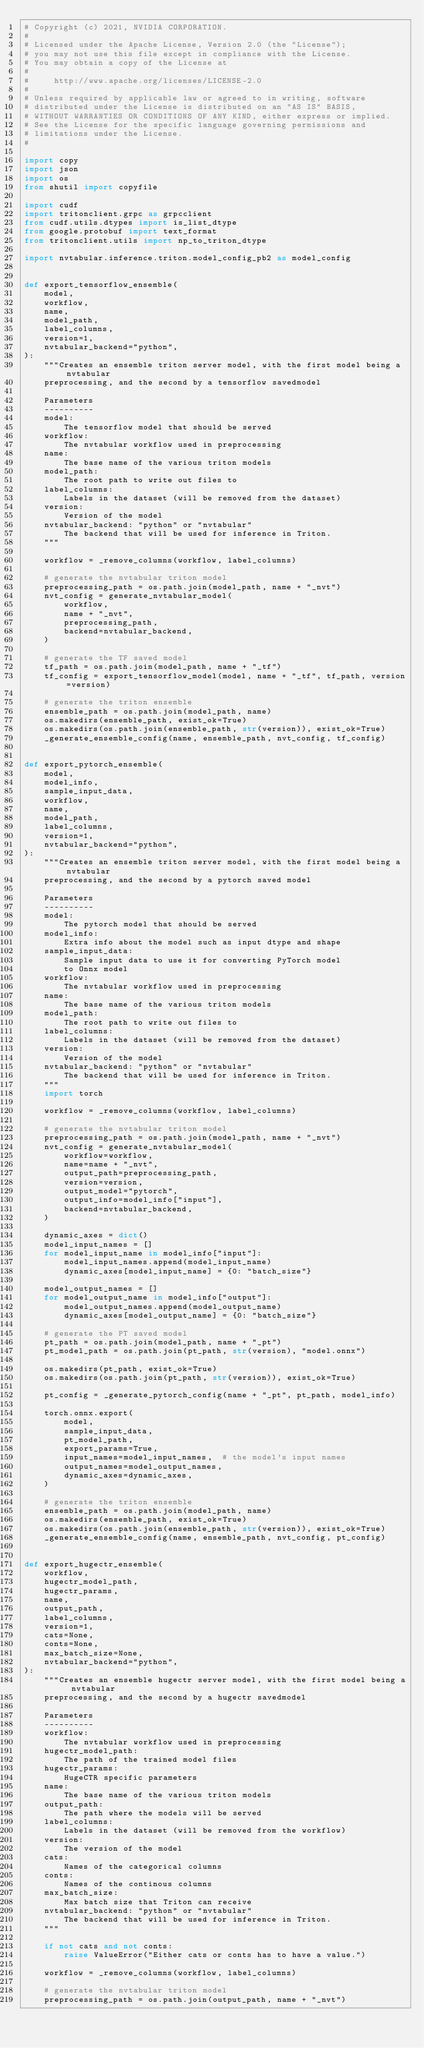Convert code to text. <code><loc_0><loc_0><loc_500><loc_500><_Python_># Copyright (c) 2021, NVIDIA CORPORATION.
#
# Licensed under the Apache License, Version 2.0 (the "License");
# you may not use this file except in compliance with the License.
# You may obtain a copy of the License at
#
#     http://www.apache.org/licenses/LICENSE-2.0
#
# Unless required by applicable law or agreed to in writing, software
# distributed under the License is distributed on an "AS IS" BASIS,
# WITHOUT WARRANTIES OR CONDITIONS OF ANY KIND, either express or implied.
# See the License for the specific language governing permissions and
# limitations under the License.
#

import copy
import json
import os
from shutil import copyfile

import cudf
import tritonclient.grpc as grpcclient
from cudf.utils.dtypes import is_list_dtype
from google.protobuf import text_format
from tritonclient.utils import np_to_triton_dtype

import nvtabular.inference.triton.model_config_pb2 as model_config


def export_tensorflow_ensemble(
    model,
    workflow,
    name,
    model_path,
    label_columns,
    version=1,
    nvtabular_backend="python",
):
    """Creates an ensemble triton server model, with the first model being a nvtabular
    preprocessing, and the second by a tensorflow savedmodel

    Parameters
    ----------
    model:
        The tensorflow model that should be served
    workflow:
        The nvtabular workflow used in preprocessing
    name:
        The base name of the various triton models
    model_path:
        The root path to write out files to
    label_columns:
        Labels in the dataset (will be removed from the dataset)
    version:
        Version of the model
    nvtabular_backend: "python" or "nvtabular"
        The backend that will be used for inference in Triton.
    """

    workflow = _remove_columns(workflow, label_columns)

    # generate the nvtabular triton model
    preprocessing_path = os.path.join(model_path, name + "_nvt")
    nvt_config = generate_nvtabular_model(
        workflow,
        name + "_nvt",
        preprocessing_path,
        backend=nvtabular_backend,
    )

    # generate the TF saved model
    tf_path = os.path.join(model_path, name + "_tf")
    tf_config = export_tensorflow_model(model, name + "_tf", tf_path, version=version)

    # generate the triton ensemble
    ensemble_path = os.path.join(model_path, name)
    os.makedirs(ensemble_path, exist_ok=True)
    os.makedirs(os.path.join(ensemble_path, str(version)), exist_ok=True)
    _generate_ensemble_config(name, ensemble_path, nvt_config, tf_config)


def export_pytorch_ensemble(
    model,
    model_info,
    sample_input_data,
    workflow,
    name,
    model_path,
    label_columns,
    version=1,
    nvtabular_backend="python",
):
    """Creates an ensemble triton server model, with the first model being a nvtabular
    preprocessing, and the second by a pytorch saved model

    Parameters
    ----------
    model:
        The pytorch model that should be served
    model_info:
        Extra info about the model such as input dtype and shape
    sample_input_data:
        Sample input data to use it for converting PyTorch model
        to Onnx model
    workflow:
        The nvtabular workflow used in preprocessing
    name:
        The base name of the various triton models
    model_path:
        The root path to write out files to
    label_columns:
        Labels in the dataset (will be removed from the dataset)
    version:
        Version of the model
    nvtabular_backend: "python" or "nvtabular"
        The backend that will be used for inference in Triton.
    """
    import torch

    workflow = _remove_columns(workflow, label_columns)

    # generate the nvtabular triton model
    preprocessing_path = os.path.join(model_path, name + "_nvt")
    nvt_config = generate_nvtabular_model(
        workflow=workflow,
        name=name + "_nvt",
        output_path=preprocessing_path,
        version=version,
        output_model="pytorch",
        output_info=model_info["input"],
        backend=nvtabular_backend,
    )

    dynamic_axes = dict()
    model_input_names = []
    for model_input_name in model_info["input"]:
        model_input_names.append(model_input_name)
        dynamic_axes[model_input_name] = {0: "batch_size"}

    model_output_names = []
    for model_output_name in model_info["output"]:
        model_output_names.append(model_output_name)
        dynamic_axes[model_output_name] = {0: "batch_size"}

    # generate the PT saved model
    pt_path = os.path.join(model_path, name + "_pt")
    pt_model_path = os.path.join(pt_path, str(version), "model.onnx")

    os.makedirs(pt_path, exist_ok=True)
    os.makedirs(os.path.join(pt_path, str(version)), exist_ok=True)

    pt_config = _generate_pytorch_config(name + "_pt", pt_path, model_info)

    torch.onnx.export(
        model,
        sample_input_data,
        pt_model_path,
        export_params=True,
        input_names=model_input_names,  # the model's input names
        output_names=model_output_names,
        dynamic_axes=dynamic_axes,
    )

    # generate the triton ensemble
    ensemble_path = os.path.join(model_path, name)
    os.makedirs(ensemble_path, exist_ok=True)
    os.makedirs(os.path.join(ensemble_path, str(version)), exist_ok=True)
    _generate_ensemble_config(name, ensemble_path, nvt_config, pt_config)


def export_hugectr_ensemble(
    workflow,
    hugectr_model_path,
    hugectr_params,
    name,
    output_path,
    label_columns,
    version=1,
    cats=None,
    conts=None,
    max_batch_size=None,
    nvtabular_backend="python",
):
    """Creates an ensemble hugectr server model, with the first model being a nvtabular
    preprocessing, and the second by a hugectr savedmodel

    Parameters
    ----------
    workflow:
        The nvtabular workflow used in preprocessing
    hugectr_model_path:
        The path of the trained model files
    hugectr_params:
        HugeCTR specific parameters
    name:
        The base name of the various triton models
    output_path:
        The path where the models will be served
    label_columns:
        Labels in the dataset (will be removed from the workflow)
    version:
        The version of the model
    cats:
        Names of the categorical columns
    conts:
        Names of the continous columns
    max_batch_size:
        Max batch size that Triton can receive
    nvtabular_backend: "python" or "nvtabular"
        The backend that will be used for inference in Triton.
    """

    if not cats and not conts:
        raise ValueError("Either cats or conts has to have a value.")

    workflow = _remove_columns(workflow, label_columns)

    # generate the nvtabular triton model
    preprocessing_path = os.path.join(output_path, name + "_nvt")</code> 